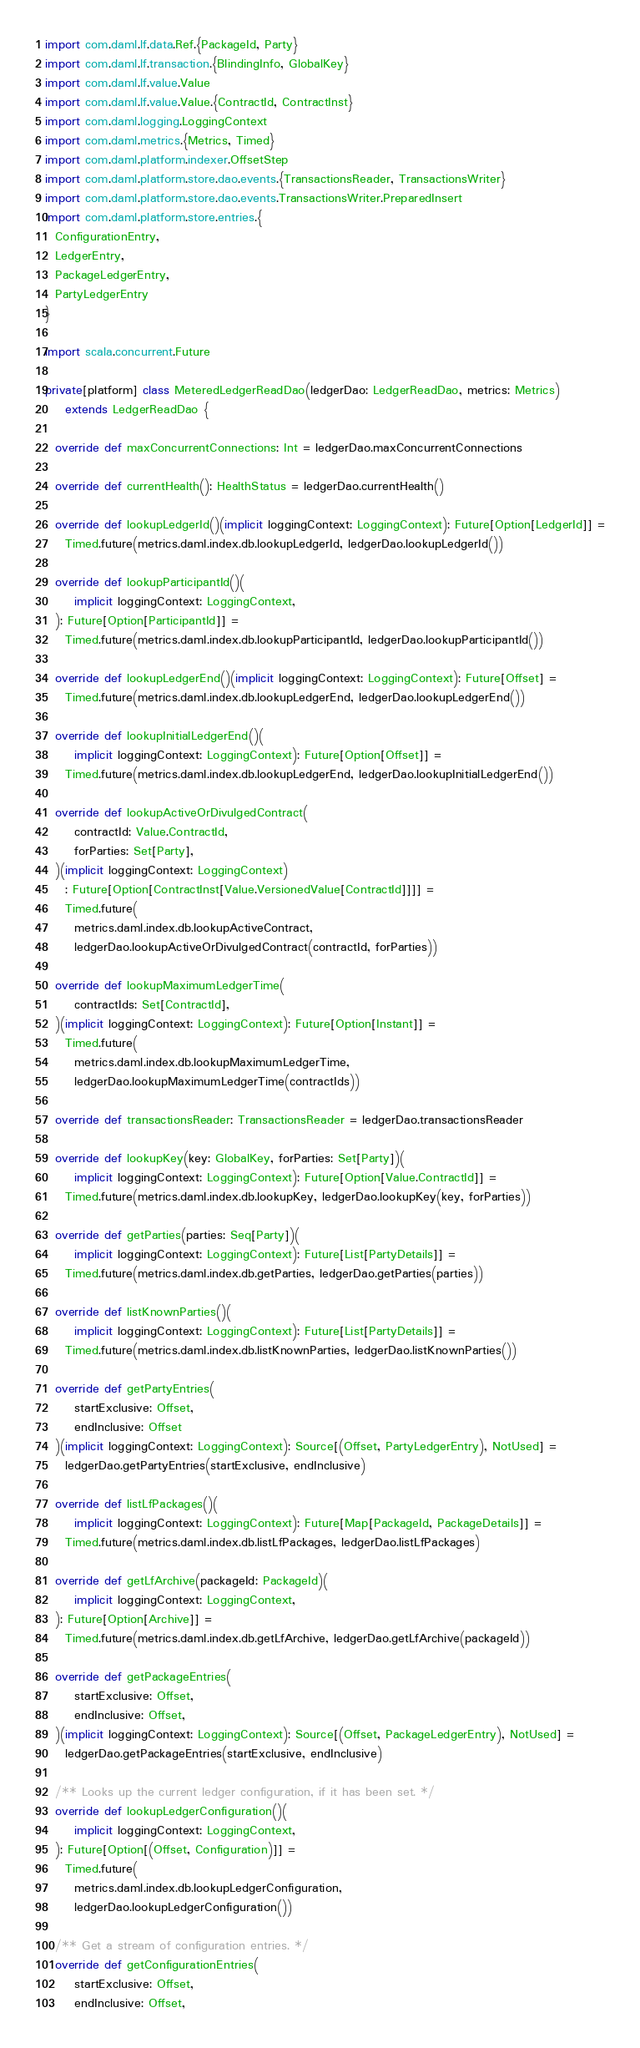<code> <loc_0><loc_0><loc_500><loc_500><_Scala_>import com.daml.lf.data.Ref.{PackageId, Party}
import com.daml.lf.transaction.{BlindingInfo, GlobalKey}
import com.daml.lf.value.Value
import com.daml.lf.value.Value.{ContractId, ContractInst}
import com.daml.logging.LoggingContext
import com.daml.metrics.{Metrics, Timed}
import com.daml.platform.indexer.OffsetStep
import com.daml.platform.store.dao.events.{TransactionsReader, TransactionsWriter}
import com.daml.platform.store.dao.events.TransactionsWriter.PreparedInsert
import com.daml.platform.store.entries.{
  ConfigurationEntry,
  LedgerEntry,
  PackageLedgerEntry,
  PartyLedgerEntry
}

import scala.concurrent.Future

private[platform] class MeteredLedgerReadDao(ledgerDao: LedgerReadDao, metrics: Metrics)
    extends LedgerReadDao {

  override def maxConcurrentConnections: Int = ledgerDao.maxConcurrentConnections

  override def currentHealth(): HealthStatus = ledgerDao.currentHealth()

  override def lookupLedgerId()(implicit loggingContext: LoggingContext): Future[Option[LedgerId]] =
    Timed.future(metrics.daml.index.db.lookupLedgerId, ledgerDao.lookupLedgerId())

  override def lookupParticipantId()(
      implicit loggingContext: LoggingContext,
  ): Future[Option[ParticipantId]] =
    Timed.future(metrics.daml.index.db.lookupParticipantId, ledgerDao.lookupParticipantId())

  override def lookupLedgerEnd()(implicit loggingContext: LoggingContext): Future[Offset] =
    Timed.future(metrics.daml.index.db.lookupLedgerEnd, ledgerDao.lookupLedgerEnd())

  override def lookupInitialLedgerEnd()(
      implicit loggingContext: LoggingContext): Future[Option[Offset]] =
    Timed.future(metrics.daml.index.db.lookupLedgerEnd, ledgerDao.lookupInitialLedgerEnd())

  override def lookupActiveOrDivulgedContract(
      contractId: Value.ContractId,
      forParties: Set[Party],
  )(implicit loggingContext: LoggingContext)
    : Future[Option[ContractInst[Value.VersionedValue[ContractId]]]] =
    Timed.future(
      metrics.daml.index.db.lookupActiveContract,
      ledgerDao.lookupActiveOrDivulgedContract(contractId, forParties))

  override def lookupMaximumLedgerTime(
      contractIds: Set[ContractId],
  )(implicit loggingContext: LoggingContext): Future[Option[Instant]] =
    Timed.future(
      metrics.daml.index.db.lookupMaximumLedgerTime,
      ledgerDao.lookupMaximumLedgerTime(contractIds))

  override def transactionsReader: TransactionsReader = ledgerDao.transactionsReader

  override def lookupKey(key: GlobalKey, forParties: Set[Party])(
      implicit loggingContext: LoggingContext): Future[Option[Value.ContractId]] =
    Timed.future(metrics.daml.index.db.lookupKey, ledgerDao.lookupKey(key, forParties))

  override def getParties(parties: Seq[Party])(
      implicit loggingContext: LoggingContext): Future[List[PartyDetails]] =
    Timed.future(metrics.daml.index.db.getParties, ledgerDao.getParties(parties))

  override def listKnownParties()(
      implicit loggingContext: LoggingContext): Future[List[PartyDetails]] =
    Timed.future(metrics.daml.index.db.listKnownParties, ledgerDao.listKnownParties())

  override def getPartyEntries(
      startExclusive: Offset,
      endInclusive: Offset
  )(implicit loggingContext: LoggingContext): Source[(Offset, PartyLedgerEntry), NotUsed] =
    ledgerDao.getPartyEntries(startExclusive, endInclusive)

  override def listLfPackages()(
      implicit loggingContext: LoggingContext): Future[Map[PackageId, PackageDetails]] =
    Timed.future(metrics.daml.index.db.listLfPackages, ledgerDao.listLfPackages)

  override def getLfArchive(packageId: PackageId)(
      implicit loggingContext: LoggingContext,
  ): Future[Option[Archive]] =
    Timed.future(metrics.daml.index.db.getLfArchive, ledgerDao.getLfArchive(packageId))

  override def getPackageEntries(
      startExclusive: Offset,
      endInclusive: Offset,
  )(implicit loggingContext: LoggingContext): Source[(Offset, PackageLedgerEntry), NotUsed] =
    ledgerDao.getPackageEntries(startExclusive, endInclusive)

  /** Looks up the current ledger configuration, if it has been set. */
  override def lookupLedgerConfiguration()(
      implicit loggingContext: LoggingContext,
  ): Future[Option[(Offset, Configuration)]] =
    Timed.future(
      metrics.daml.index.db.lookupLedgerConfiguration,
      ledgerDao.lookupLedgerConfiguration())

  /** Get a stream of configuration entries. */
  override def getConfigurationEntries(
      startExclusive: Offset,
      endInclusive: Offset,</code> 